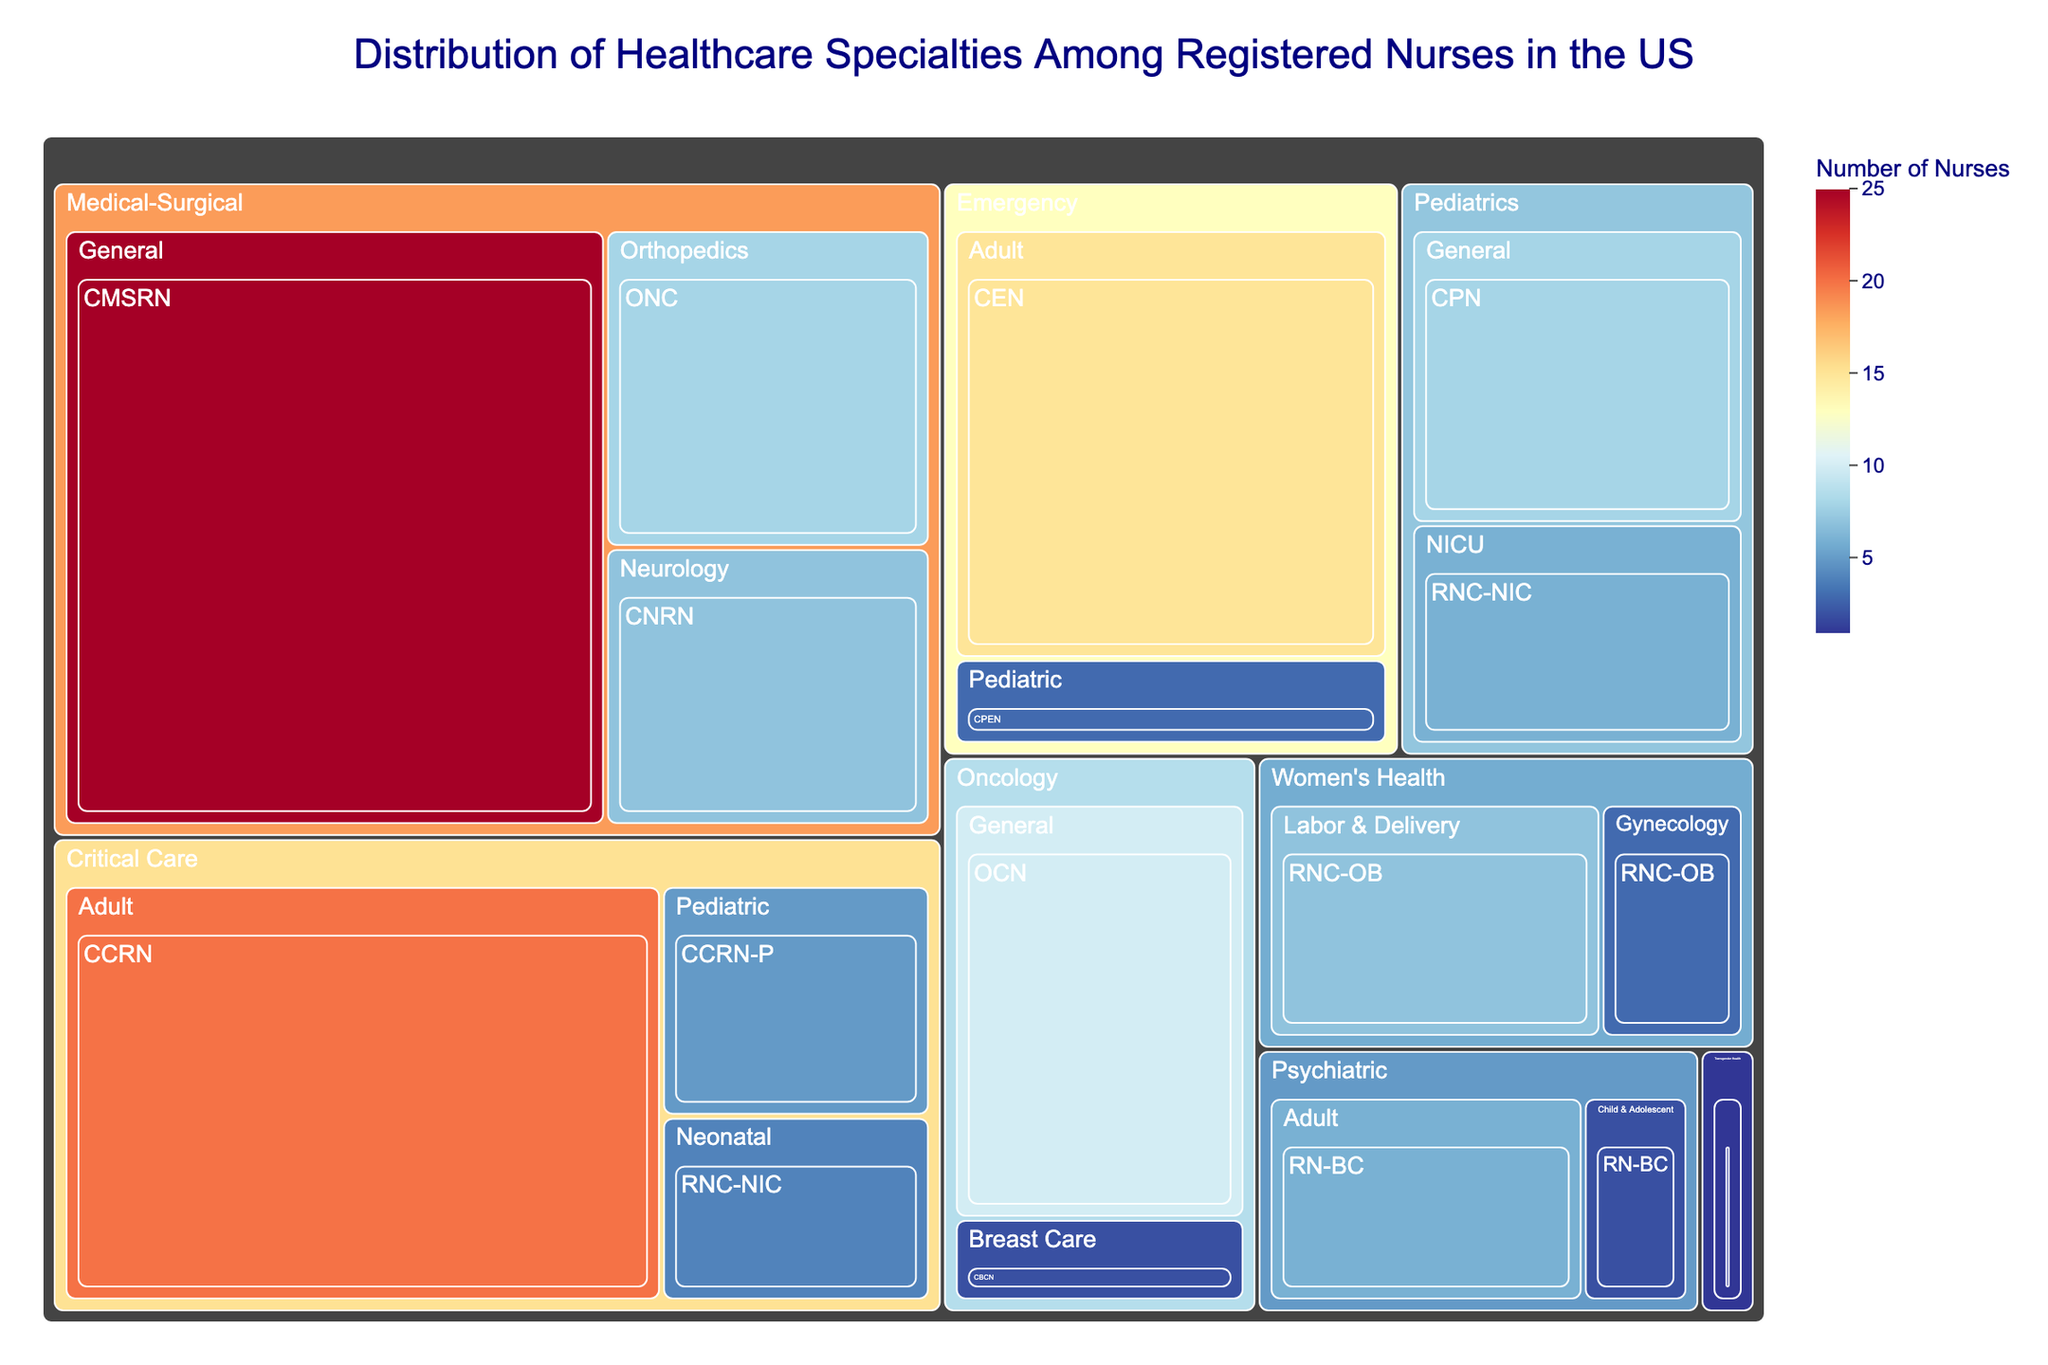How many registered nurses specialize in Critical Care, Adult? First, find the Critical Care section, then find the Adult subcategory within Critical Care, and look at the value next to it.
Answer: 20 Which specialty has the highest number of registered nurses? Compare all the values for each specialty and identify the one with the highest number. Medical-Surgical has the highest value of 25.
Answer: Medical-Surgical What's the total number of registered nurses in the Emergency specialty? Add the values of all subcategories under the Emergency specialty (15 for Adult and 3 for Pediatric). Sum: 15 + 3 = 18.
Answer: 18 Compare the number of registered nurses in Pediatric NICU with those in Critical Care Neonatal. Which has more? Look under Pediatrics for NICU (6) and under Critical Care for Neonatal (4). Compare the two values.
Answer: Pediatric NICU Which subspecialty under Medical-Surgical has the fewest registered nurses? Look at the values for all subspecialties under Medical-Surgical: General (25), Orthopedics (8), Neurology (7). The smallest value is 7 in Neurology.
Answer: Neurology What's the combined number of registered nurses specializing in Emergency (Adult and Pediatric) and Women's Health (Labor & Delivery and Gynecology)? Add the values for Emergency's subspecialties (15 + 3) and Women's Health's subspecialties (7 + 3), then sum these totals. Sum: (15 + 3) + (7 + 3) = 28.
Answer: 28 What is the ratio of registered nurses in Medical-Surgical Orthopedics compared to Oncology General? Find the values for Medical-Surgical Orthopedics (8) and Oncology General (10). Compute the ratio 8/10.
Answer: 0.8 How many more registered nurses are in Medical-Surgical General compared to Critical Care Adult? Subtract the value of Critical Care Adult (20) from Medical-Surgical General (25). Difference: 25 - 20 = 5.
Answer: 5 What's the percentage of registered nurses in Transgender Health Hormone Therapy out of the total number of registered nurses in the data? First, calculate the total number of registered nurses by summing all values. Then, divide the number in Transgender Health Hormone Therapy (1) by this total and multiply by 100 to get the percentage. Total = 125. Percentage: (1 / 125) * 100 = 0.8%.
Answer: 0.8% How many registered nurses are certified in RNC-OB across Women's Health specialties? Sum the values for all subcategories under Women's Health that have RNC-OB certification: Labor & Delivery (7) and Gynecology (3). Sum: 7 + 3 = 10.
Answer: 10 